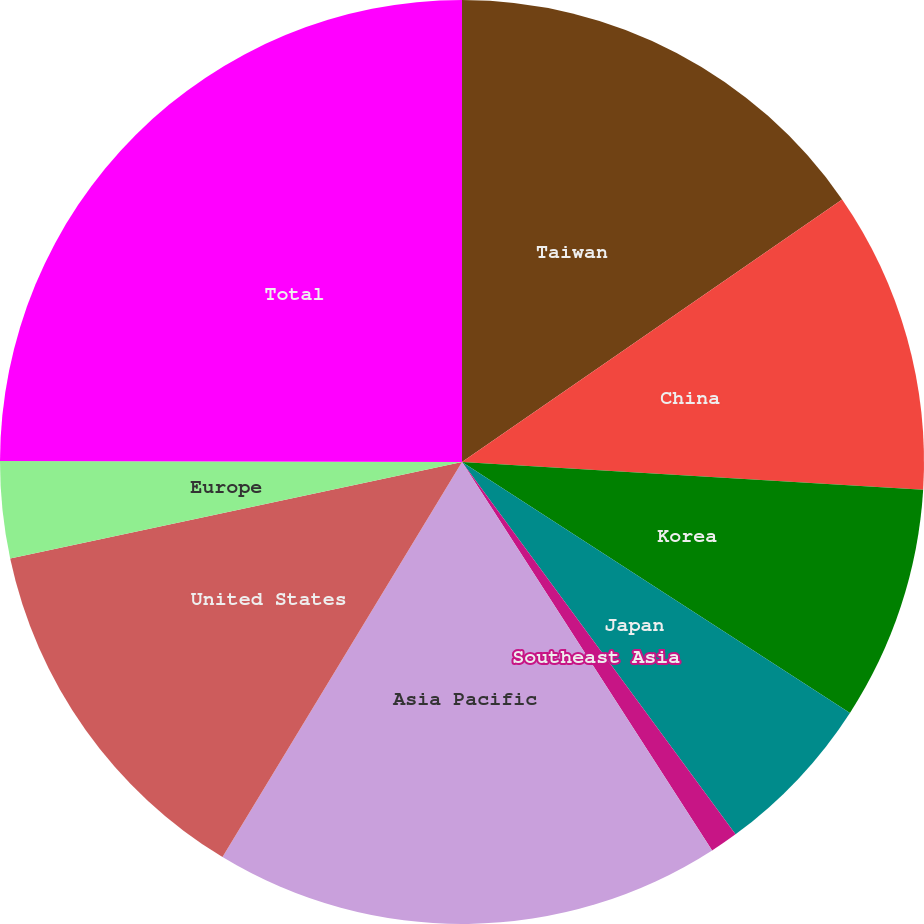Convert chart to OTSL. <chart><loc_0><loc_0><loc_500><loc_500><pie_chart><fcel>Taiwan<fcel>China<fcel>Korea<fcel>Japan<fcel>Southeast Asia<fcel>Asia Pacific<fcel>United States<fcel>Europe<fcel>Total<nl><fcel>15.38%<fcel>10.58%<fcel>8.18%<fcel>5.78%<fcel>0.98%<fcel>17.78%<fcel>12.98%<fcel>3.38%<fcel>24.97%<nl></chart> 